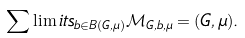<formula> <loc_0><loc_0><loc_500><loc_500>\sum \lim i t s _ { b \in B ( G , \mu ) } \mathcal { M } _ { G , b , \mu } = ( G , \mu ) .</formula> 